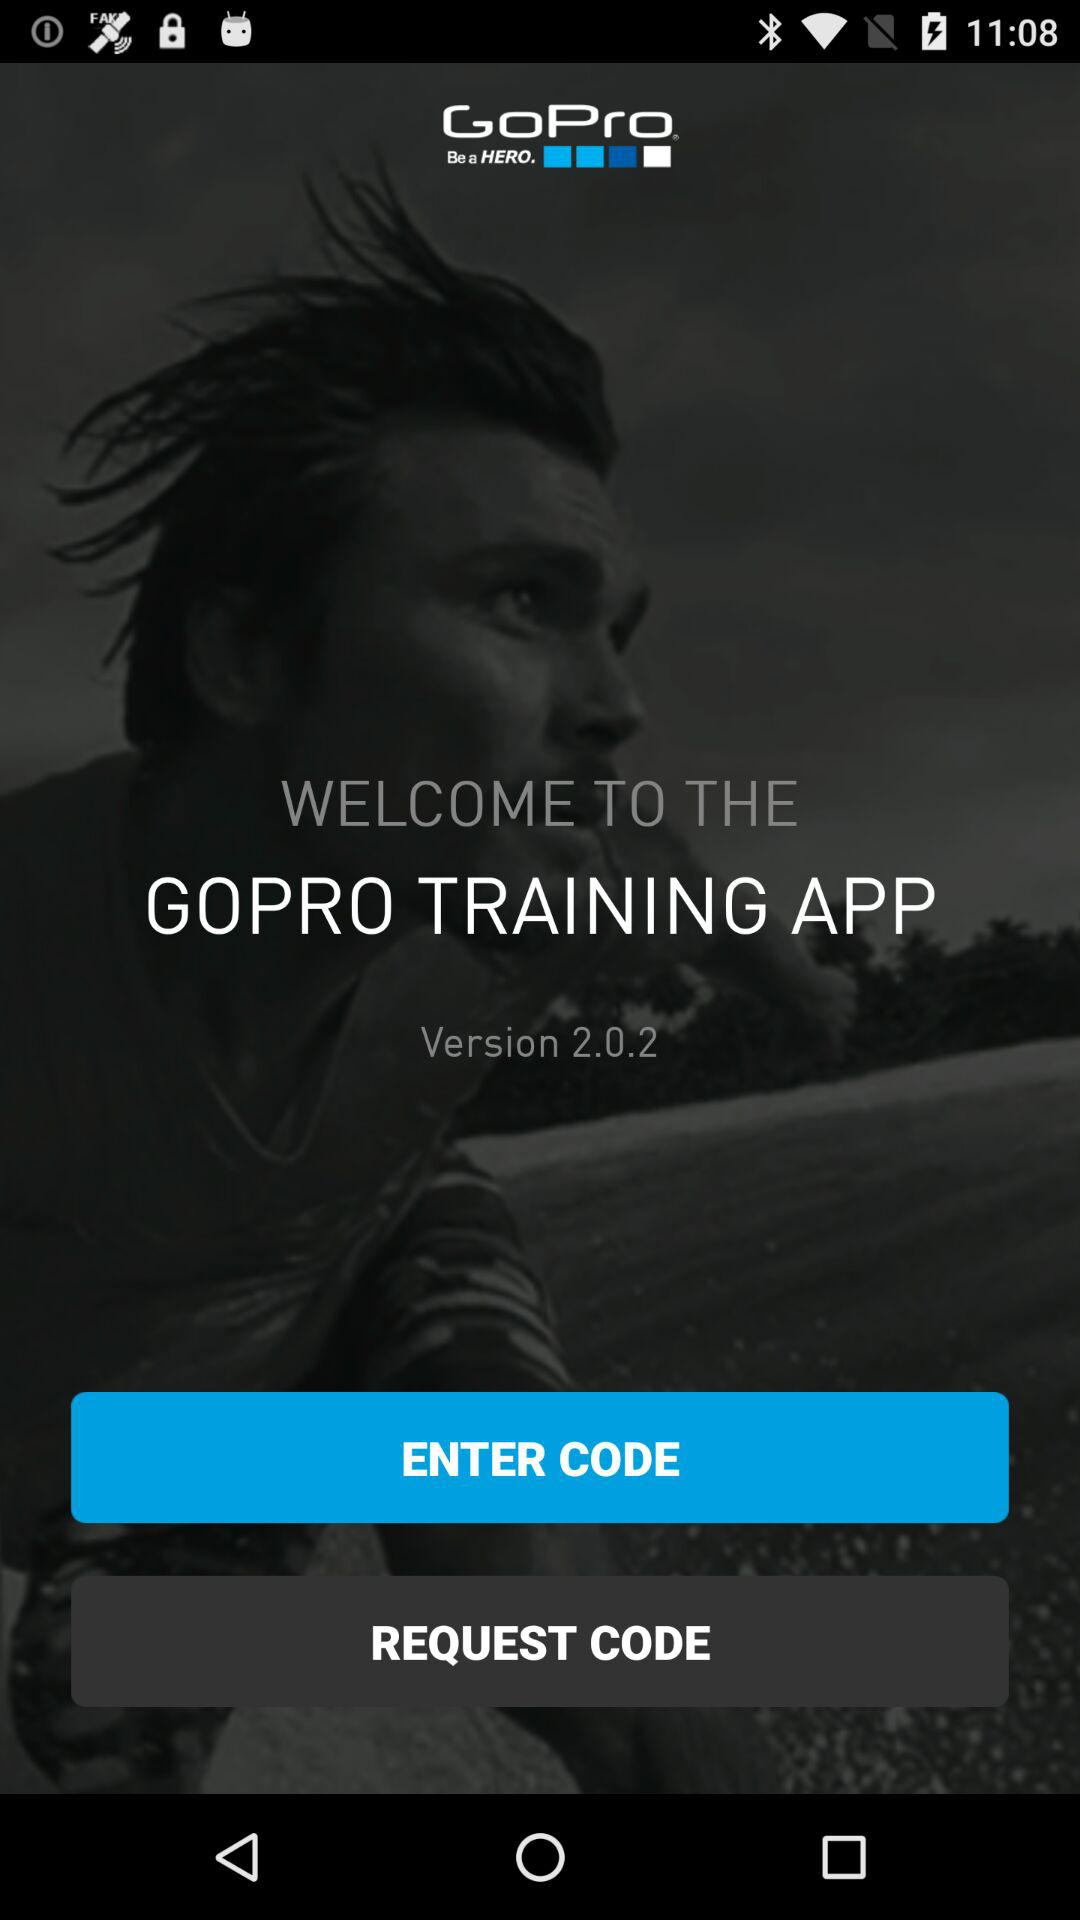What version of the application is it? The version of the application is 2.0.2. 